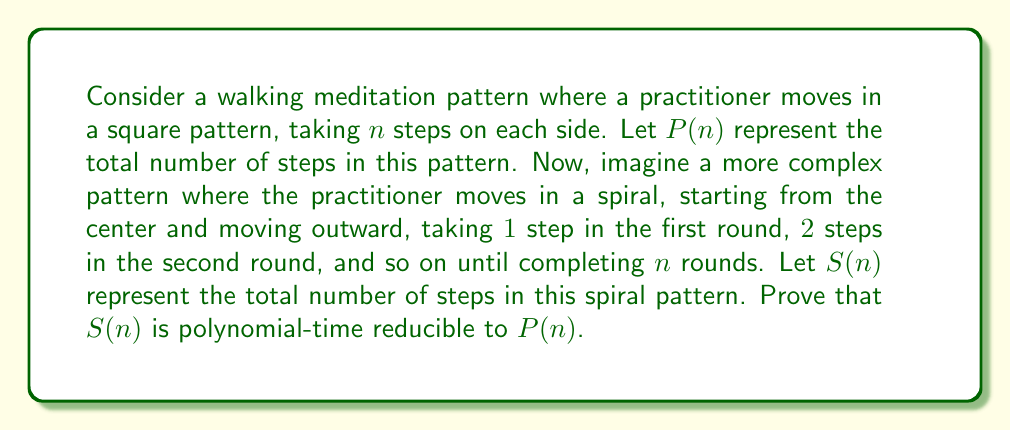What is the answer to this math problem? To prove that $S(n)$ is polynomial-time reducible to $P(n)$, we need to show that there exists a polynomial-time algorithm that can compute $S(n)$ using $P(n)$ as a subroutine. Let's approach this step-by-step:

1. First, let's express $P(n)$ and $S(n)$ mathematically:

   $P(n) = 4n$ (4 sides with $n$ steps each)
   $S(n) = 1 + 2 + 3 + ... + n = \frac{n(n+1)}{2}$ (sum of arithmetic sequence)

2. To reduce $S(n)$ to $P(n)$, we need to find a way to express $S(n)$ in terms of $P(n)$ or use $P(n)$ to compute $S(n)$.

3. Observe that:
   $$S(n) = \frac{n(n+1)}{2} = \frac{n^2 + n}{2}$$

4. We can rewrite this as:
   $$S(n) = \frac{n^2}{2} + \frac{n}{2}$$

5. Now, let's express this in terms of $P(n)$:
   $$S(n) = \frac{1}{8}P(n)^2 + \frac{1}{8}P(n)$$

   This is because $P(n) = 4n$, so $n = \frac{1}{4}P(n)$

6. To compute $S(n)$:
   a) Compute $P(n)$
   b) Calculate $\frac{1}{8}P(n)^2 + \frac{1}{8}P(n)$

7. This reduction is polynomial-time because:
   a) Computing $P(n)$ takes constant time
   b) The subsequent calculation involves only basic arithmetic operations

Therefore, we have shown that $S(n)$ can be computed in polynomial time using $P(n)$ as a subroutine, proving that $S(n)$ is polynomial-time reducible to $P(n)$.
Answer: $S(n)$ is polynomial-time reducible to $P(n)$, as demonstrated by the reduction $S(n) = \frac{1}{8}P(n)^2 + \frac{1}{8}P(n)$, which can be computed in polynomial time. 